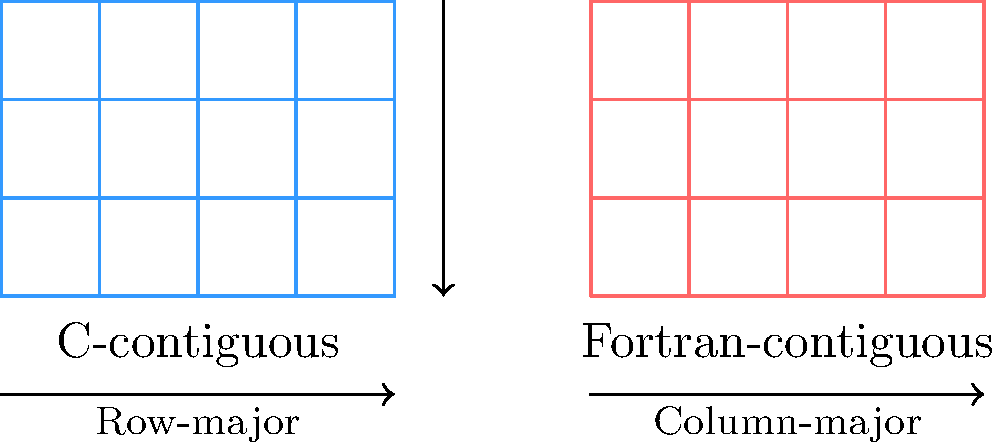Given the memory layout of C-contiguous and Fortran-contiguous arrays in NumPy as shown in the diagram, which of the following operations would be more efficient on a C-contiguous array: element-wise operations along rows or along columns? Explain your reasoning based on cache locality and memory access patterns. To answer this question, we need to consider the memory layout and its impact on performance:

1. C-contiguous arrays (row-major order):
   - Elements in a row are stored contiguously in memory.
   - Moving from one element to the next in a row involves accessing adjacent memory locations.

2. Cache locality:
   - Modern CPUs use cache to speed up memory access.
   - Accessing contiguous memory locations is faster due to better cache utilization.

3. Element-wise operations along rows:
   - For C-contiguous arrays, elements in a row are adjacent in memory.
   - This results in efficient cache usage and fewer cache misses.
   - The CPU can prefetch data more effectively, leading to better performance.

4. Element-wise operations along columns:
   - For C-contiguous arrays, elements in a column are not adjacent in memory.
   - This leads to more cache misses and less efficient memory access.
   - The CPU needs to jump larger memory distances between elements, reducing performance.

5. Performance comparison:
   - Row-wise operations will be more efficient due to better cache locality.
   - Column-wise operations will be less efficient due to cache misses and memory access patterns.

Therefore, element-wise operations along rows would be more efficient on a C-contiguous array in NumPy.
Answer: Element-wise operations along rows 